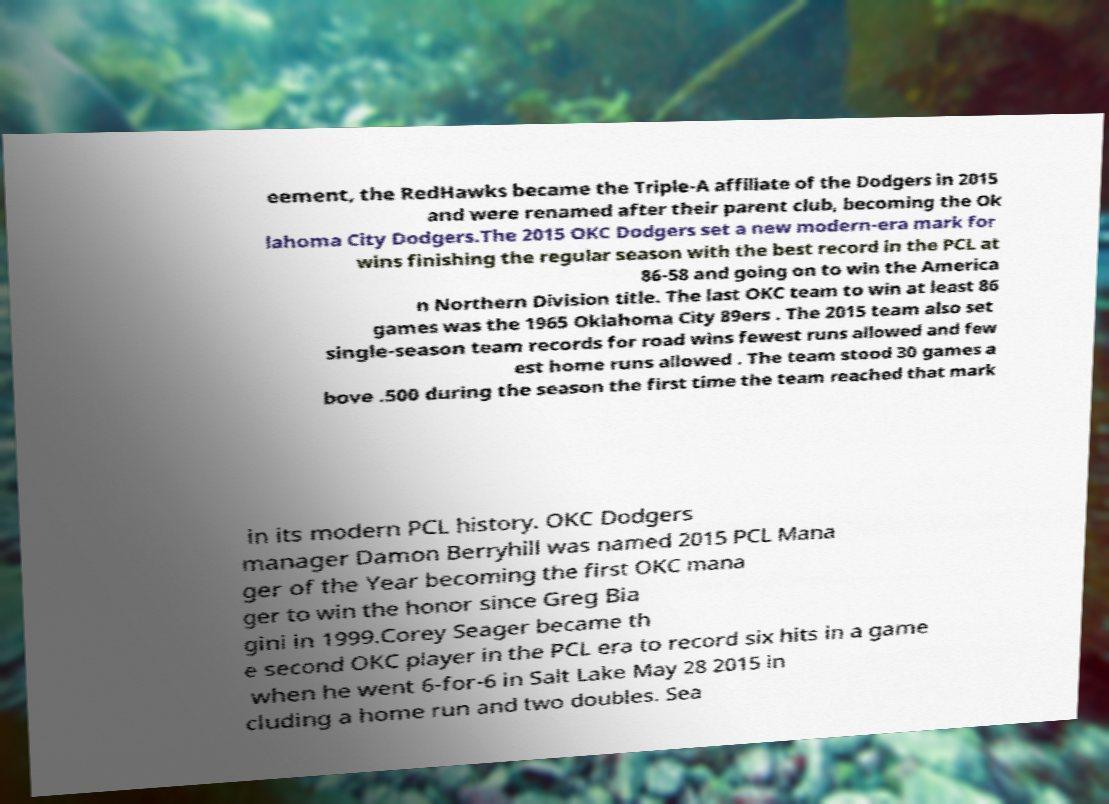There's text embedded in this image that I need extracted. Can you transcribe it verbatim? eement, the RedHawks became the Triple-A affiliate of the Dodgers in 2015 and were renamed after their parent club, becoming the Ok lahoma City Dodgers.The 2015 OKC Dodgers set a new modern-era mark for wins finishing the regular season with the best record in the PCL at 86-58 and going on to win the America n Northern Division title. The last OKC team to win at least 86 games was the 1965 Oklahoma City 89ers . The 2015 team also set single-season team records for road wins fewest runs allowed and few est home runs allowed . The team stood 30 games a bove .500 during the season the first time the team reached that mark in its modern PCL history. OKC Dodgers manager Damon Berryhill was named 2015 PCL Mana ger of the Year becoming the first OKC mana ger to win the honor since Greg Bia gini in 1999.Corey Seager became th e second OKC player in the PCL era to record six hits in a game when he went 6-for-6 in Salt Lake May 28 2015 in cluding a home run and two doubles. Sea 